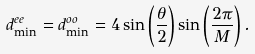Convert formula to latex. <formula><loc_0><loc_0><loc_500><loc_500>d ^ { e e } _ { \min } = d ^ { o o } _ { \min } = 4 \sin \left ( \frac { \theta } { 2 } \right ) \sin \left ( \frac { 2 \pi } { M } \right ) .</formula> 